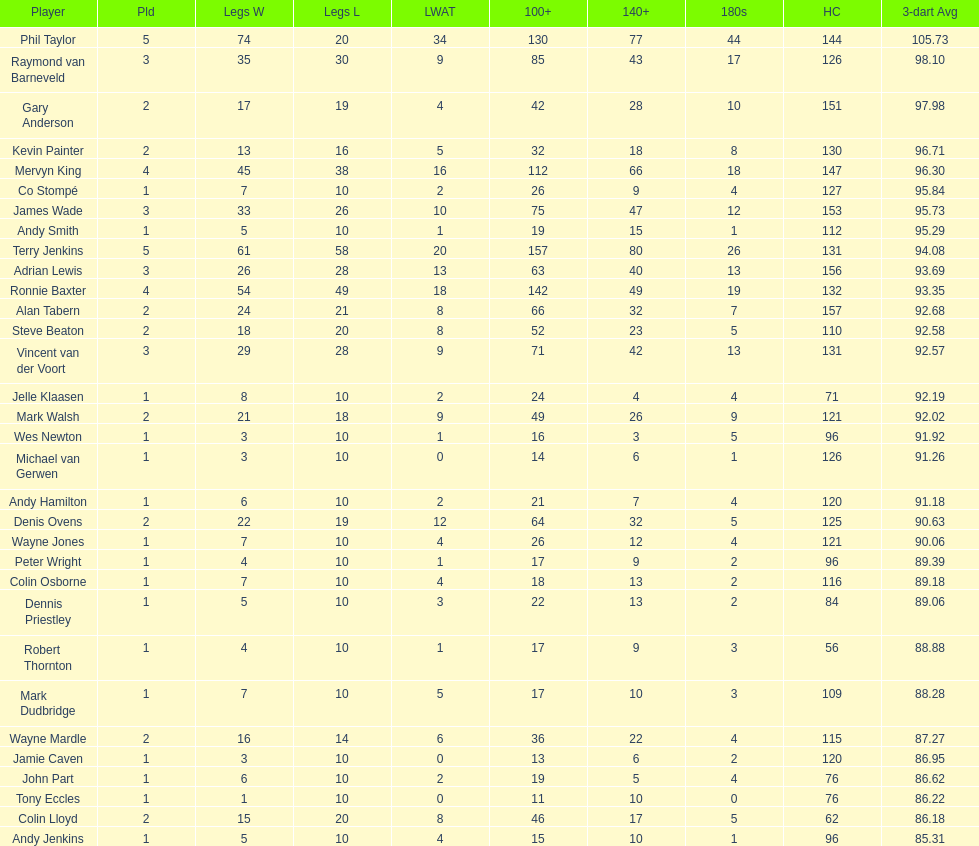Which player has his high checkout as 116? Colin Osborne. 